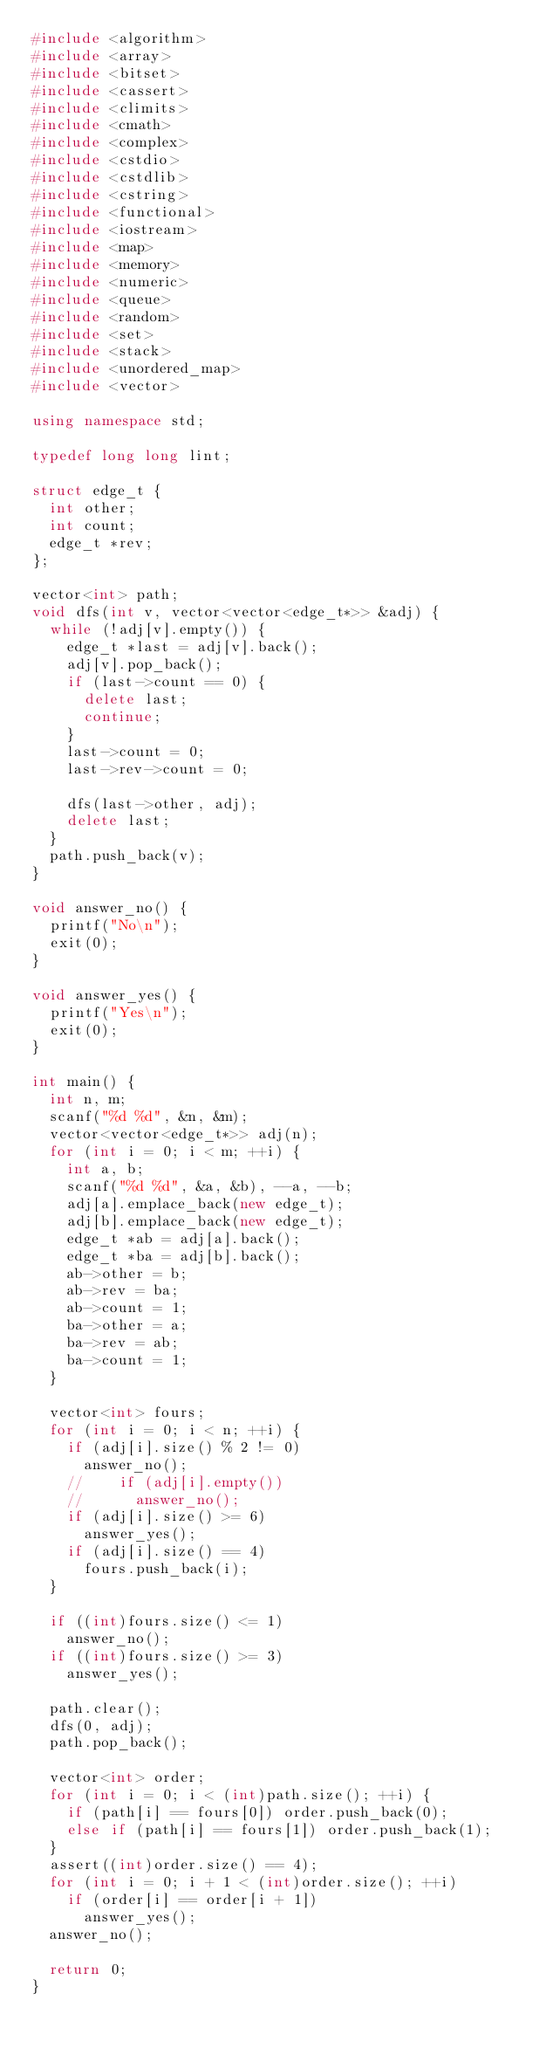Convert code to text. <code><loc_0><loc_0><loc_500><loc_500><_C++_>#include <algorithm>
#include <array>
#include <bitset>
#include <cassert>
#include <climits>
#include <cmath>
#include <complex>
#include <cstdio>
#include <cstdlib>
#include <cstring>
#include <functional>
#include <iostream>
#include <map>
#include <memory>
#include <numeric>
#include <queue>
#include <random>
#include <set>
#include <stack>
#include <unordered_map>
#include <vector>

using namespace std;

typedef long long lint;

struct edge_t {
  int other;
  int count;
  edge_t *rev;
};

vector<int> path;
void dfs(int v, vector<vector<edge_t*>> &adj) {
  while (!adj[v].empty()) {
    edge_t *last = adj[v].back();
    adj[v].pop_back();
    if (last->count == 0) {
      delete last;
      continue;
    }
    last->count = 0;
    last->rev->count = 0;

    dfs(last->other, adj);
    delete last;
  }
  path.push_back(v);
}

void answer_no() {
  printf("No\n");
  exit(0);
}

void answer_yes() {
  printf("Yes\n");
  exit(0);
}

int main() {
  int n, m;
  scanf("%d %d", &n, &m);
  vector<vector<edge_t*>> adj(n);
  for (int i = 0; i < m; ++i) {
    int a, b;
    scanf("%d %d", &a, &b), --a, --b;
    adj[a].emplace_back(new edge_t);
    adj[b].emplace_back(new edge_t);
    edge_t *ab = adj[a].back();
    edge_t *ba = adj[b].back();
    ab->other = b;
    ab->rev = ba;
    ab->count = 1;
    ba->other = a;
    ba->rev = ab;
    ba->count = 1;
  }

  vector<int> fours;
  for (int i = 0; i < n; ++i) {
    if (adj[i].size() % 2 != 0)
      answer_no();
    //    if (adj[i].empty())
    //      answer_no();
    if (adj[i].size() >= 6)
      answer_yes();
    if (adj[i].size() == 4)
      fours.push_back(i);
  }

  if ((int)fours.size() <= 1)
    answer_no();
  if ((int)fours.size() >= 3)
    answer_yes();

  path.clear();
  dfs(0, adj);
  path.pop_back();

  vector<int> order;
  for (int i = 0; i < (int)path.size(); ++i) {
    if (path[i] == fours[0]) order.push_back(0);
    else if (path[i] == fours[1]) order.push_back(1);
  }
  assert((int)order.size() == 4);
  for (int i = 0; i + 1 < (int)order.size(); ++i)
    if (order[i] == order[i + 1])
      answer_yes();
  answer_no();

  return 0;
}
</code> 